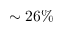Convert formula to latex. <formula><loc_0><loc_0><loc_500><loc_500>\sim 2 6 \%</formula> 